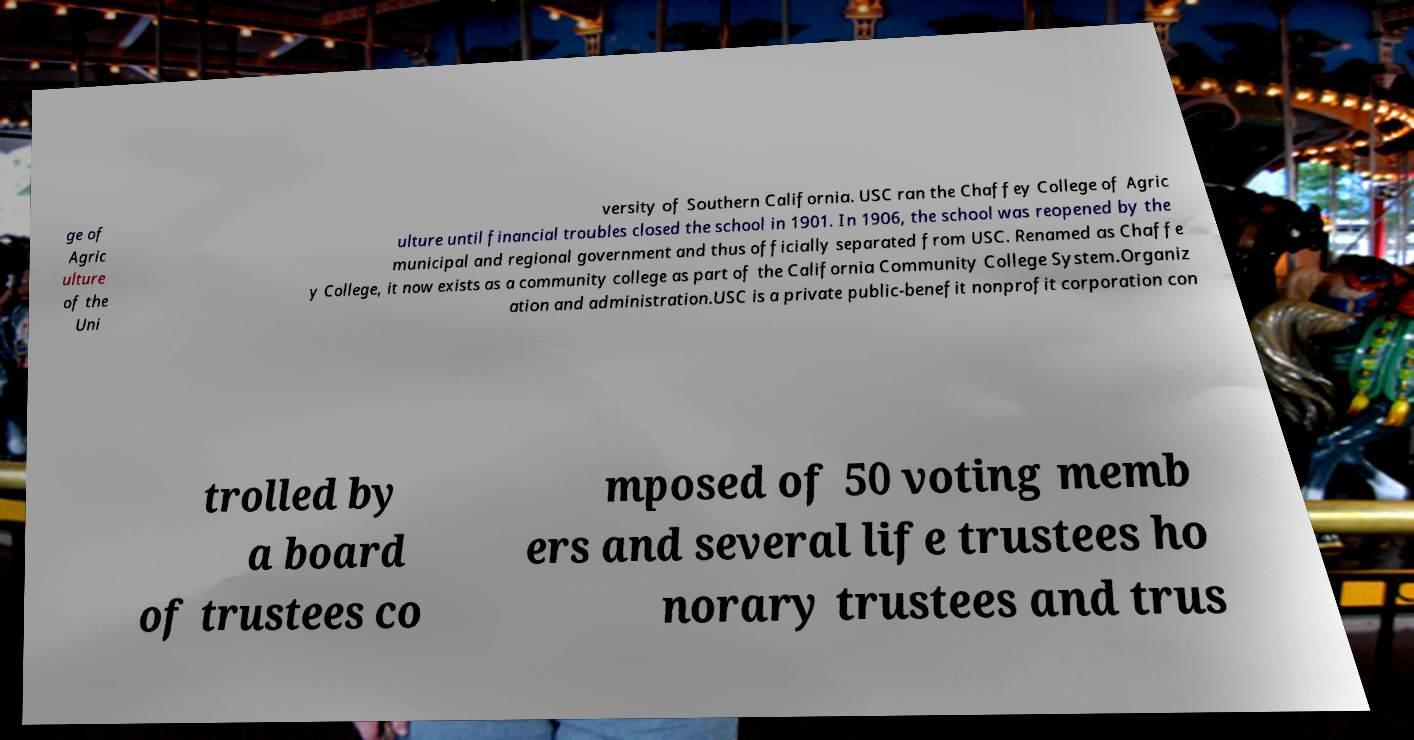Can you read and provide the text displayed in the image?This photo seems to have some interesting text. Can you extract and type it out for me? ge of Agric ulture of the Uni versity of Southern California. USC ran the Chaffey College of Agric ulture until financial troubles closed the school in 1901. In 1906, the school was reopened by the municipal and regional government and thus officially separated from USC. Renamed as Chaffe y College, it now exists as a community college as part of the California Community College System.Organiz ation and administration.USC is a private public-benefit nonprofit corporation con trolled by a board of trustees co mposed of 50 voting memb ers and several life trustees ho norary trustees and trus 